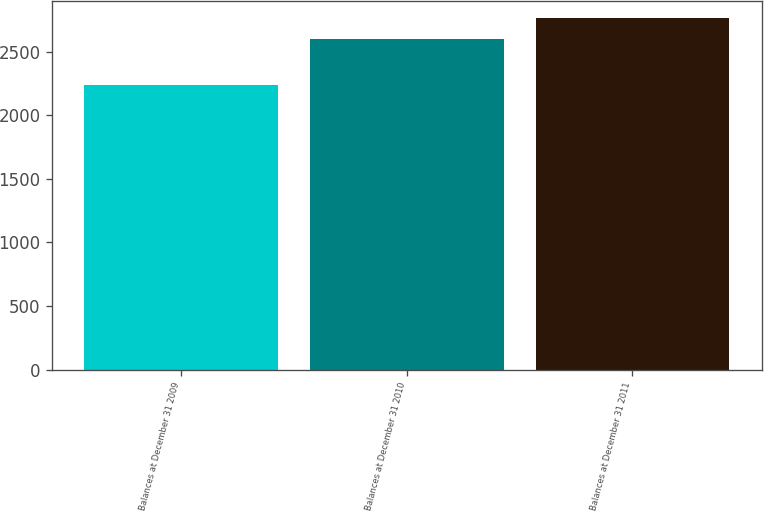Convert chart to OTSL. <chart><loc_0><loc_0><loc_500><loc_500><bar_chart><fcel>Balances at December 31 2009<fcel>Balances at December 31 2010<fcel>Balances at December 31 2011<nl><fcel>2240.1<fcel>2599.4<fcel>2765.2<nl></chart> 